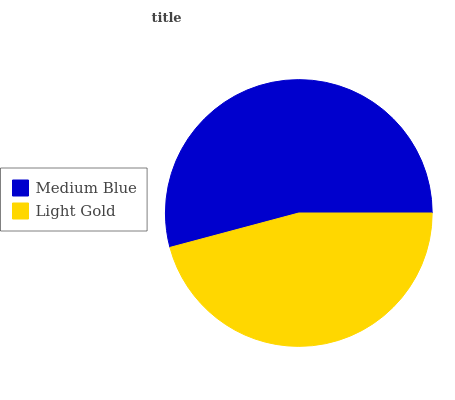Is Light Gold the minimum?
Answer yes or no. Yes. Is Medium Blue the maximum?
Answer yes or no. Yes. Is Light Gold the maximum?
Answer yes or no. No. Is Medium Blue greater than Light Gold?
Answer yes or no. Yes. Is Light Gold less than Medium Blue?
Answer yes or no. Yes. Is Light Gold greater than Medium Blue?
Answer yes or no. No. Is Medium Blue less than Light Gold?
Answer yes or no. No. Is Medium Blue the high median?
Answer yes or no. Yes. Is Light Gold the low median?
Answer yes or no. Yes. Is Light Gold the high median?
Answer yes or no. No. Is Medium Blue the low median?
Answer yes or no. No. 